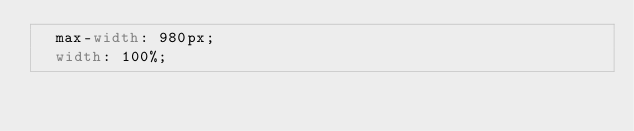<code> <loc_0><loc_0><loc_500><loc_500><_CSS_>  max-width: 980px;
  width: 100%;</code> 